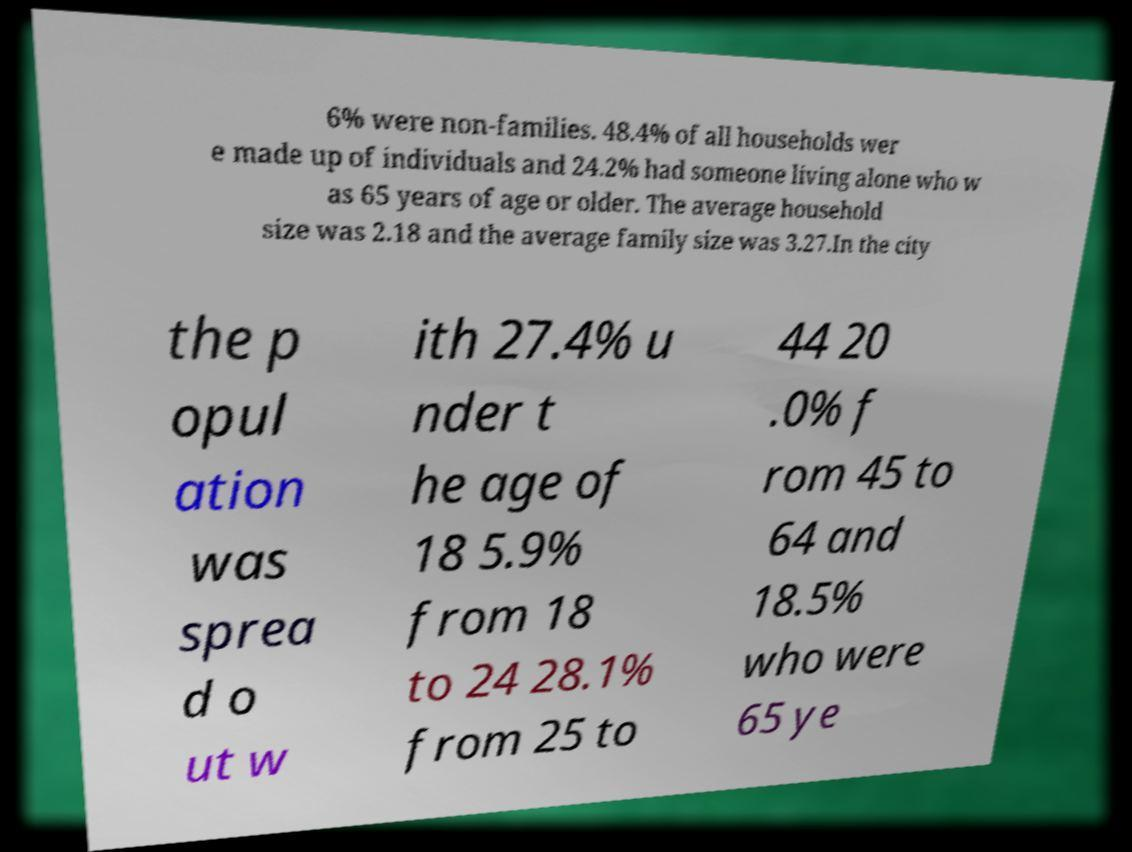Please identify and transcribe the text found in this image. 6% were non-families. 48.4% of all households wer e made up of individuals and 24.2% had someone living alone who w as 65 years of age or older. The average household size was 2.18 and the average family size was 3.27.In the city the p opul ation was sprea d o ut w ith 27.4% u nder t he age of 18 5.9% from 18 to 24 28.1% from 25 to 44 20 .0% f rom 45 to 64 and 18.5% who were 65 ye 